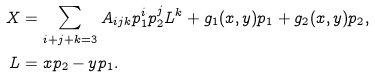Convert formula to latex. <formula><loc_0><loc_0><loc_500><loc_500>X & = \sum _ { i + j + k = 3 } A _ { i j k } p _ { 1 } ^ { i } p _ { 2 } ^ { j } L ^ { k } + g _ { 1 } ( x , y ) p _ { 1 } + g _ { 2 } ( x , y ) p _ { 2 } , \\ L & = x p _ { 2 } - y p _ { 1 } .</formula> 